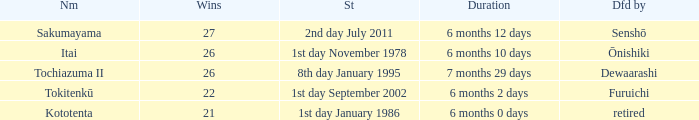Which duration was defeated by retired? 6 months 0 days. 